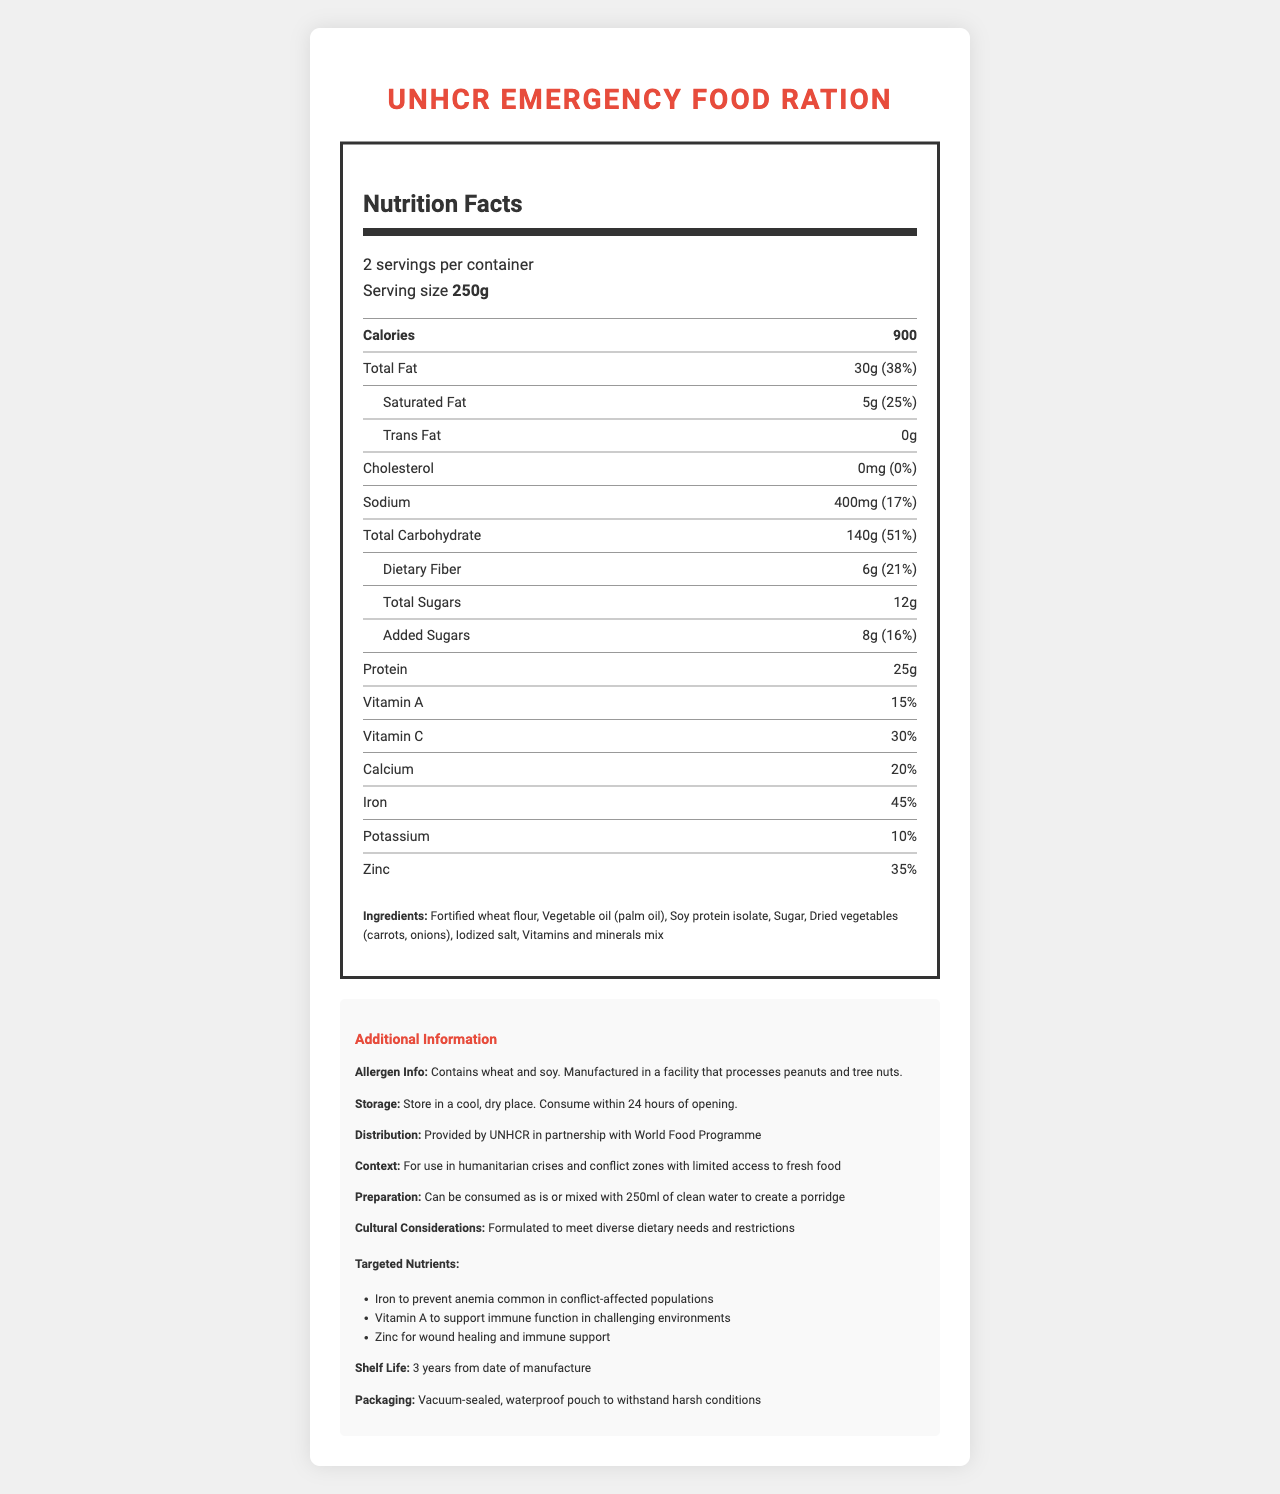What is the serving size of the UNHCR Emergency Food Ration? The serving size is mentioned in the document as "Serving size: 250g".
Answer: 250g How many calories are there per serving? The document states "Calories per serving: 900".
Answer: 900 List three main ingredients of the UNHCR Emergency Food Ration. These ingredients are mentioned under the "Ingredients" section of the document.
Answer: Fortified wheat flour, Vegetable oil (palm oil), Soy protein isolate How much protein does each serving contain? The document lists "Protein: 25g".
Answer: 25g What is the shelf life of this food ration? The shelf life is specified in the additional information section as "3 years from date of manufacture".
Answer: 3 years from date of manufacture How many servings are in one container? The document specifies "2 servings per container".
Answer: 2 What percentage of the daily value of iron does one serving provide? The document states "Iron: 45%" under the nutrition facts section.
Answer: 45% Which of the following vitamins is present in the highest percentage per serving? A. Vitamin A B. Vitamin C C. Calcium The percentage daily value of Vitamin C (30%) is higher than that of Vitamin A (15%) and Calcium (20%).
Answer: B. Vitamin C Which nutrient is specifically targeted to prevent anemia? I. Iron II. Vitamin A III. Zinc IV. Potassium The document mentions "Iron to prevent anemia common in conflict-affected populations".
Answer: I. Iron Can this ration be consumed without any preparation? The preparation instructions state: "Can be consumed as is or mixed with 250ml of clean water to create a porridge."
Answer: Yes Describe the main purpose and contents of the UNHCR Emergency Food Ration. This summary captures the document's focus on the nutritional contents, intended use, and ingredients, highlighting its role in supporting displaced populations in crisis situations.
Answer: The UNHCR Emergency Food Ration is designed for use in humanitarian crises and conflict zones with limited access to fresh food. It provides essential nutrients such as iron, Vitamin A, and zinc to support immune function and prevent common deficiencies. The ration includes fortified wheat flour, vegetable oil, soy protein isolate, sugar, dried vegetables, iodized salt, and a vitamins and minerals mix. It has a long shelf life of 3 years and comes in a vacuum-sealed, waterproof pouch. Who is the manufacturer of the UNHCR Emergency Food Ration? The document does not specify the manufacturer name.
Answer: Cannot be determined Is the ration gluten-free? The allergen information states that the product contains wheat.
Answer: No What is the sodium content per serving? The nutrition facts list sodium content as "400mg".
Answer: 400mg Is this food ration suitable for people with nut allergies? A. Yes B. No The allergen information indicates that the product is manufactured in a facility that processes peanuts and tree nuts.
Answer: B. No 